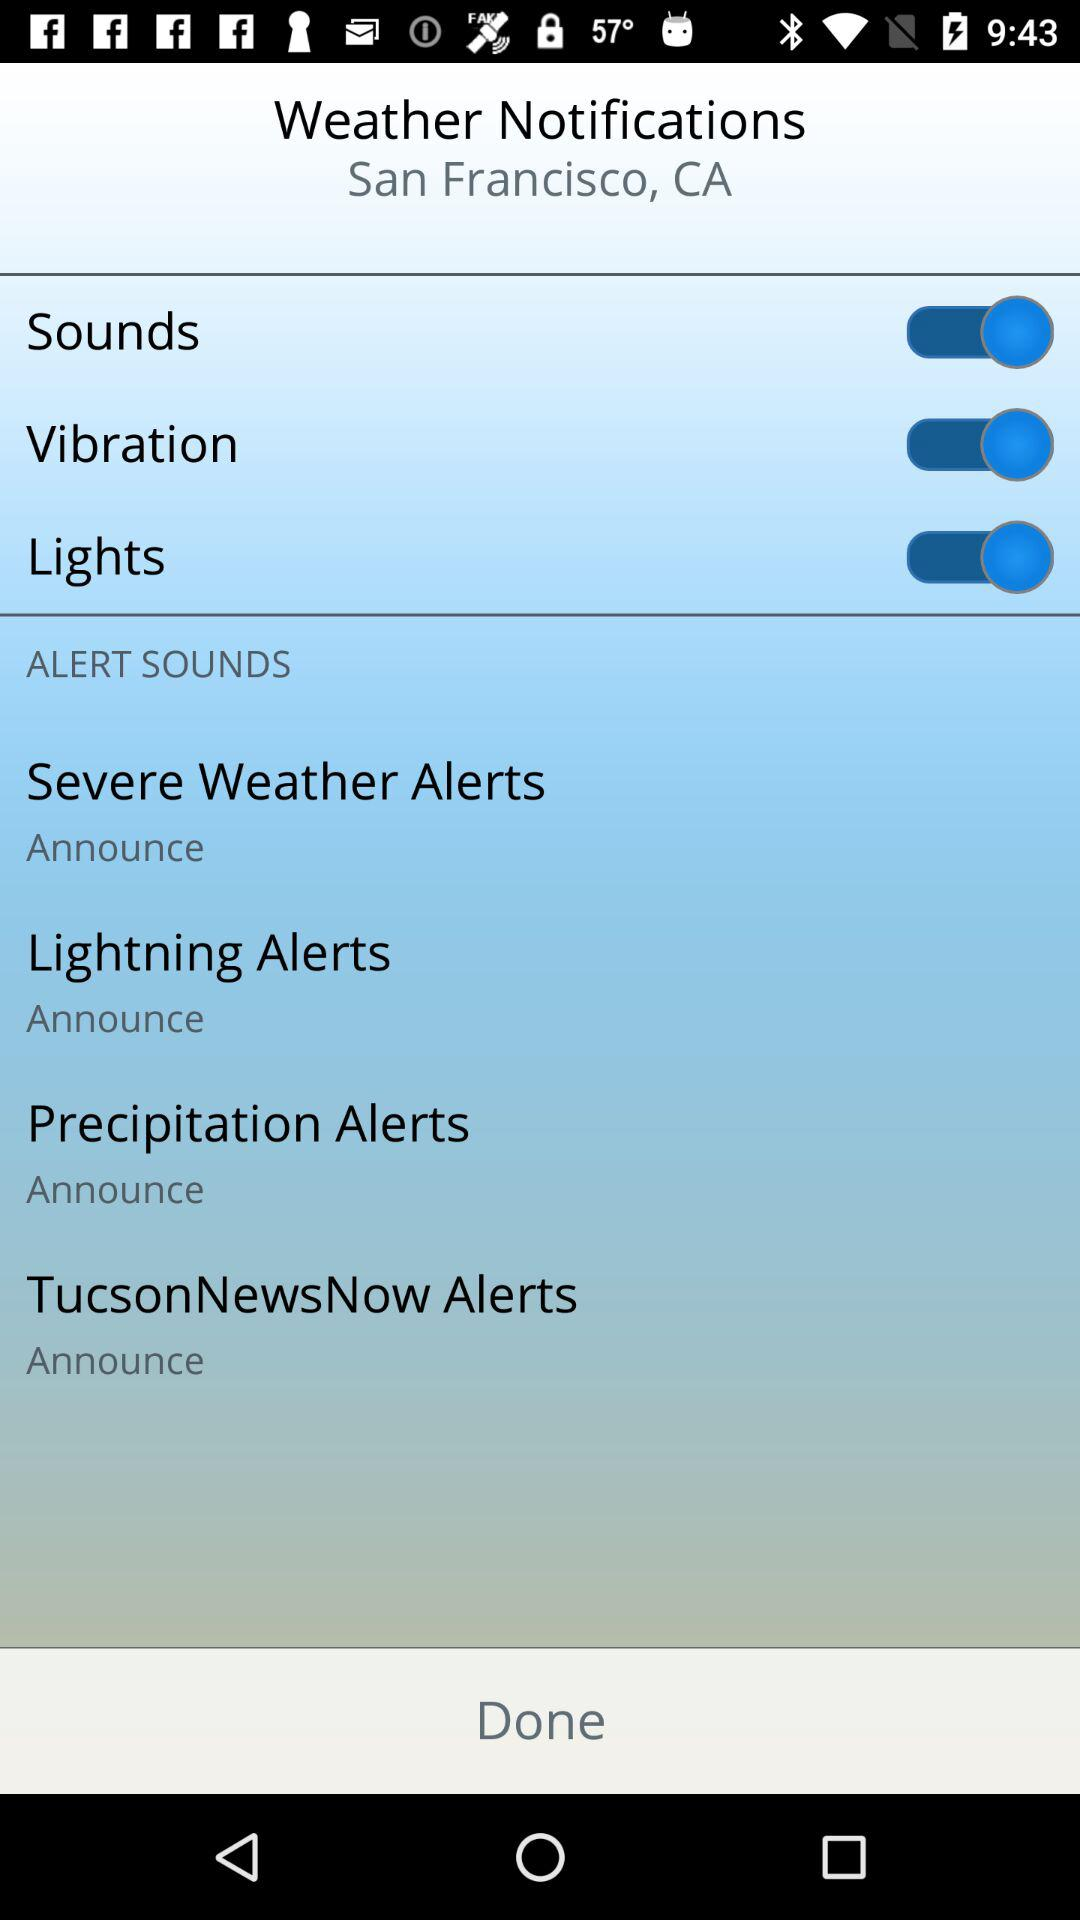How many alert types are there?
Answer the question using a single word or phrase. 4 